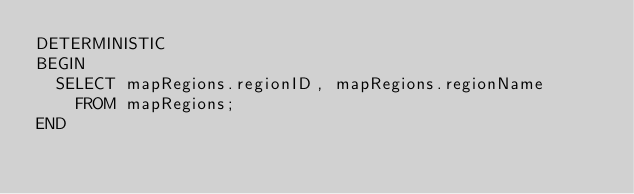Convert code to text. <code><loc_0><loc_0><loc_500><loc_500><_SQL_>DETERMINISTIC
BEGIN
  SELECT mapRegions.regionID, mapRegions.regionName
    FROM mapRegions;
END</code> 